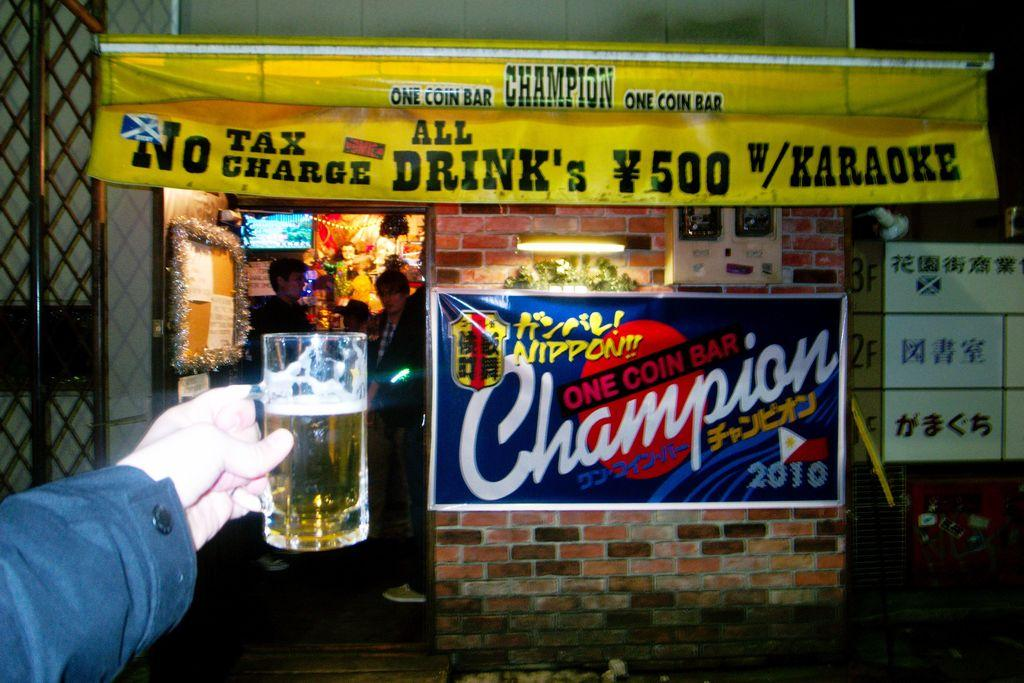<image>
Summarize the visual content of the image. Someone holds a beer mug in front of Champion One Coin Bar. 